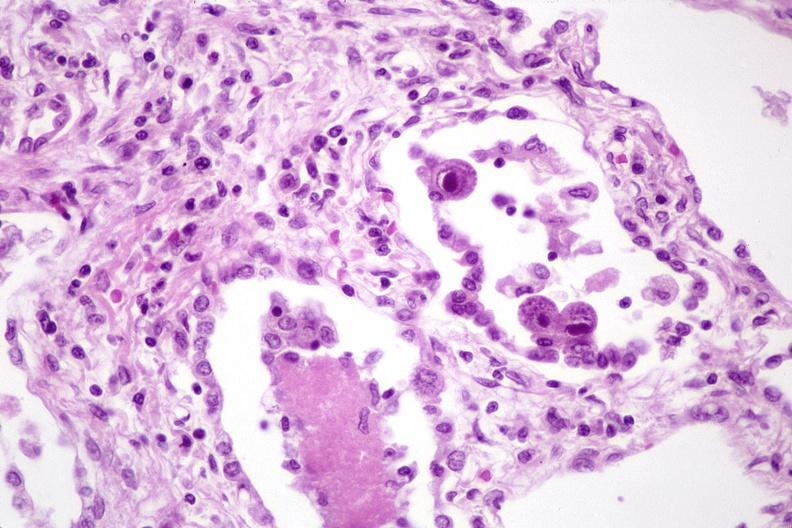does normal immature infant show lung, cyomegalovirus pneumonia and pneumocystis pneumonia?
Answer the question using a single word or phrase. No 